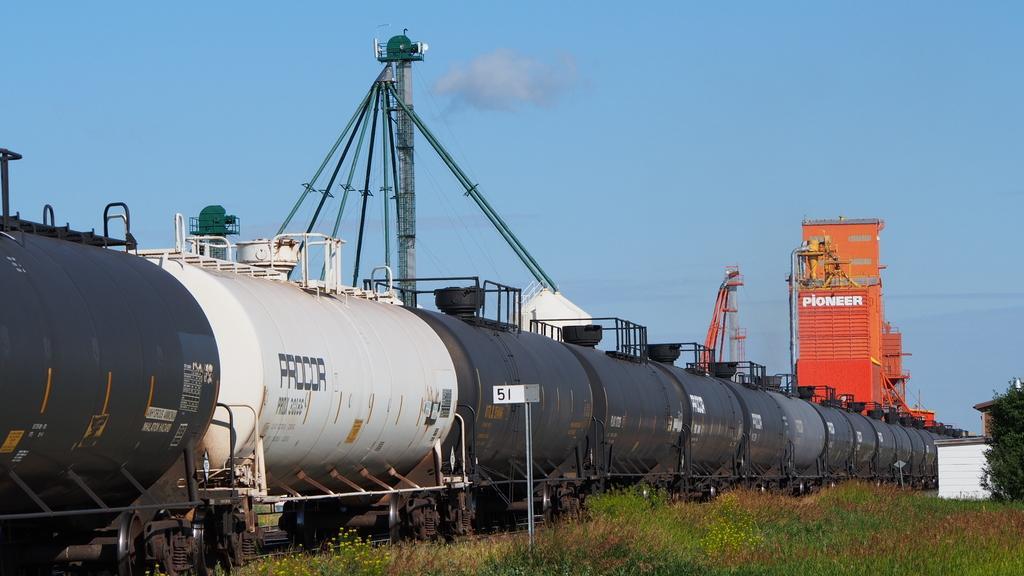Could you give a brief overview of what you see in this image? In this picture there is a train in the center of the image and there is grassland at the bottom side of the image. 